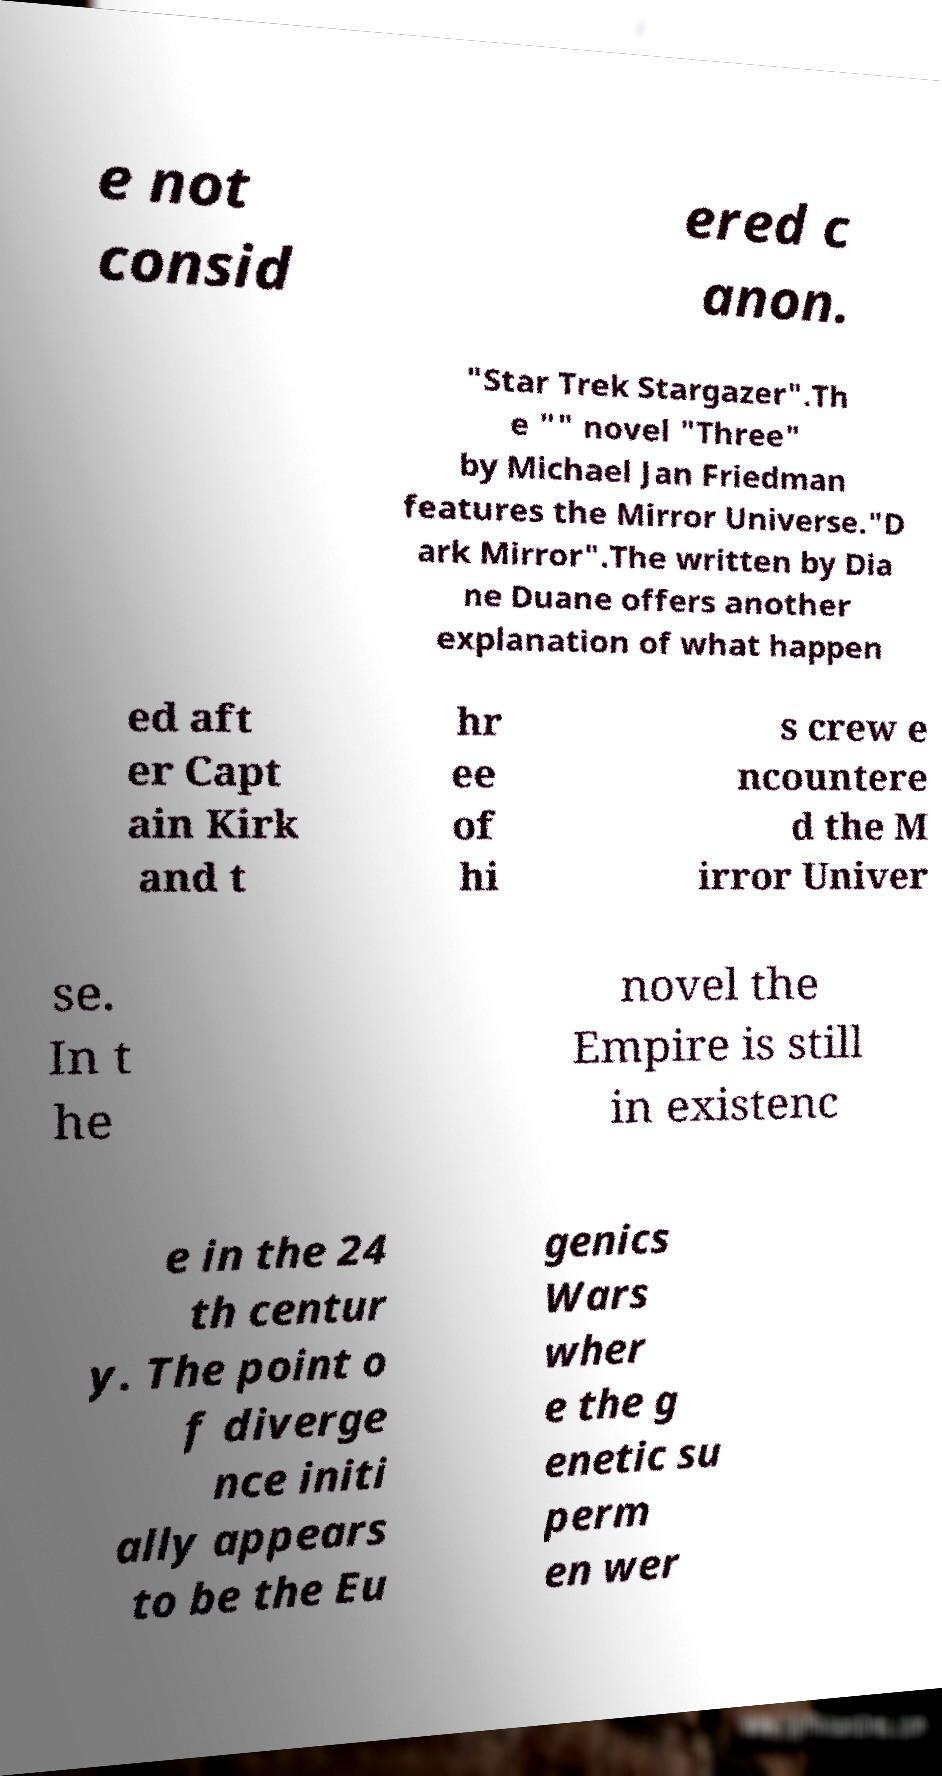What messages or text are displayed in this image? I need them in a readable, typed format. e not consid ered c anon. "Star Trek Stargazer".Th e "" novel "Three" by Michael Jan Friedman features the Mirror Universe."D ark Mirror".The written by Dia ne Duane offers another explanation of what happen ed aft er Capt ain Kirk and t hr ee of hi s crew e ncountere d the M irror Univer se. In t he novel the Empire is still in existenc e in the 24 th centur y. The point o f diverge nce initi ally appears to be the Eu genics Wars wher e the g enetic su perm en wer 